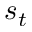<formula> <loc_0><loc_0><loc_500><loc_500>s _ { t }</formula> 